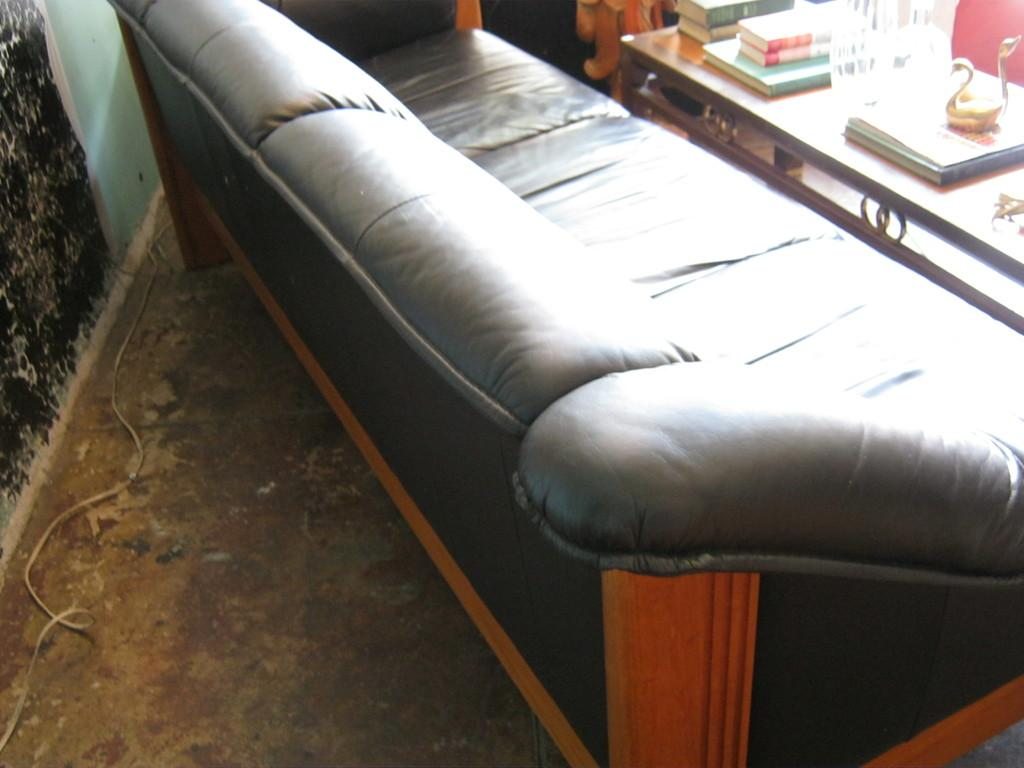What type of furniture is present in the image? There is a sofa in the image. What items can be seen on the table in the image? There are books on a table in the image. How many icicles are hanging from the sofa in the image? There are no icicles present in the image; it is an indoor scene with a sofa and a table with books. 